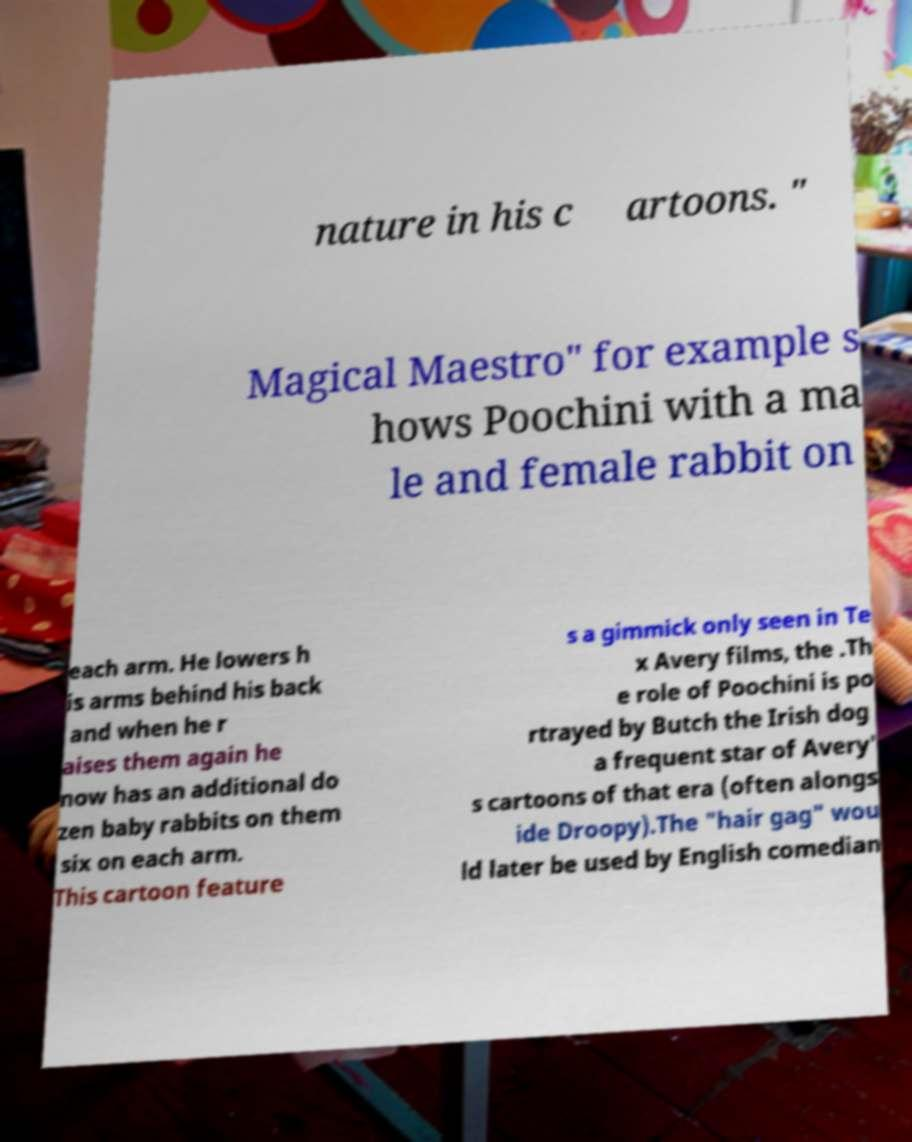I need the written content from this picture converted into text. Can you do that? nature in his c artoons. " Magical Maestro" for example s hows Poochini with a ma le and female rabbit on each arm. He lowers h is arms behind his back and when he r aises them again he now has an additional do zen baby rabbits on them six on each arm. This cartoon feature s a gimmick only seen in Te x Avery films, the .Th e role of Poochini is po rtrayed by Butch the Irish dog a frequent star of Avery' s cartoons of that era (often alongs ide Droopy).The "hair gag" wou ld later be used by English comedian 